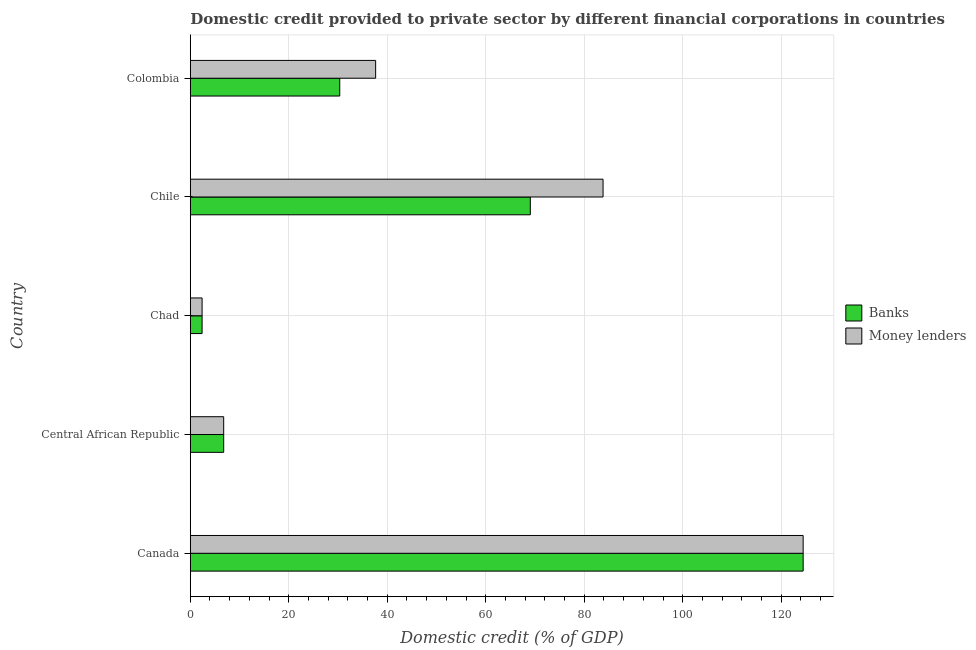Are the number of bars on each tick of the Y-axis equal?
Provide a short and direct response. Yes. How many bars are there on the 1st tick from the top?
Ensure brevity in your answer.  2. How many bars are there on the 4th tick from the bottom?
Provide a succinct answer. 2. What is the label of the 5th group of bars from the top?
Your response must be concise. Canada. What is the domestic credit provided by banks in Colombia?
Your answer should be very brief. 30.35. Across all countries, what is the maximum domestic credit provided by money lenders?
Give a very brief answer. 124.46. Across all countries, what is the minimum domestic credit provided by banks?
Offer a very short reply. 2.4. In which country was the domestic credit provided by money lenders minimum?
Provide a succinct answer. Chad. What is the total domestic credit provided by banks in the graph?
Give a very brief answer. 233.04. What is the difference between the domestic credit provided by banks in Canada and that in Chile?
Provide a succinct answer. 55.41. What is the difference between the domestic credit provided by banks in Chad and the domestic credit provided by money lenders in Chile?
Provide a short and direct response. -81.43. What is the average domestic credit provided by banks per country?
Ensure brevity in your answer.  46.61. What is the difference between the domestic credit provided by money lenders and domestic credit provided by banks in Colombia?
Ensure brevity in your answer.  7.29. What is the ratio of the domestic credit provided by money lenders in Central African Republic to that in Colombia?
Ensure brevity in your answer.  0.18. Is the domestic credit provided by money lenders in Canada less than that in Chad?
Make the answer very short. No. What is the difference between the highest and the second highest domestic credit provided by money lenders?
Offer a terse response. 40.64. What is the difference between the highest and the lowest domestic credit provided by money lenders?
Make the answer very short. 122.06. In how many countries, is the domestic credit provided by money lenders greater than the average domestic credit provided by money lenders taken over all countries?
Keep it short and to the point. 2. Is the sum of the domestic credit provided by money lenders in Chile and Colombia greater than the maximum domestic credit provided by banks across all countries?
Your answer should be compact. No. What does the 2nd bar from the top in Canada represents?
Provide a short and direct response. Banks. What does the 1st bar from the bottom in Chad represents?
Your answer should be very brief. Banks. How many bars are there?
Give a very brief answer. 10. Are all the bars in the graph horizontal?
Ensure brevity in your answer.  Yes. What is the difference between two consecutive major ticks on the X-axis?
Ensure brevity in your answer.  20. Are the values on the major ticks of X-axis written in scientific E-notation?
Make the answer very short. No. Does the graph contain any zero values?
Keep it short and to the point. No. How many legend labels are there?
Offer a very short reply. 2. How are the legend labels stacked?
Ensure brevity in your answer.  Vertical. What is the title of the graph?
Your answer should be compact. Domestic credit provided to private sector by different financial corporations in countries. What is the label or title of the X-axis?
Your answer should be compact. Domestic credit (% of GDP). What is the Domestic credit (% of GDP) of Banks in Canada?
Your answer should be very brief. 124.46. What is the Domestic credit (% of GDP) of Money lenders in Canada?
Make the answer very short. 124.46. What is the Domestic credit (% of GDP) in Banks in Central African Republic?
Provide a succinct answer. 6.78. What is the Domestic credit (% of GDP) in Money lenders in Central African Republic?
Provide a succinct answer. 6.78. What is the Domestic credit (% of GDP) in Banks in Chad?
Keep it short and to the point. 2.4. What is the Domestic credit (% of GDP) of Money lenders in Chad?
Provide a succinct answer. 2.4. What is the Domestic credit (% of GDP) in Banks in Chile?
Give a very brief answer. 69.05. What is the Domestic credit (% of GDP) of Money lenders in Chile?
Offer a terse response. 83.82. What is the Domestic credit (% of GDP) in Banks in Colombia?
Give a very brief answer. 30.35. What is the Domestic credit (% of GDP) of Money lenders in Colombia?
Keep it short and to the point. 37.64. Across all countries, what is the maximum Domestic credit (% of GDP) of Banks?
Offer a very short reply. 124.46. Across all countries, what is the maximum Domestic credit (% of GDP) of Money lenders?
Make the answer very short. 124.46. Across all countries, what is the minimum Domestic credit (% of GDP) of Banks?
Your answer should be compact. 2.4. Across all countries, what is the minimum Domestic credit (% of GDP) in Money lenders?
Provide a short and direct response. 2.4. What is the total Domestic credit (% of GDP) in Banks in the graph?
Make the answer very short. 233.04. What is the total Domestic credit (% of GDP) in Money lenders in the graph?
Make the answer very short. 255.11. What is the difference between the Domestic credit (% of GDP) of Banks in Canada and that in Central African Republic?
Your response must be concise. 117.68. What is the difference between the Domestic credit (% of GDP) in Money lenders in Canada and that in Central African Republic?
Ensure brevity in your answer.  117.68. What is the difference between the Domestic credit (% of GDP) of Banks in Canada and that in Chad?
Provide a succinct answer. 122.06. What is the difference between the Domestic credit (% of GDP) of Money lenders in Canada and that in Chad?
Ensure brevity in your answer.  122.06. What is the difference between the Domestic credit (% of GDP) of Banks in Canada and that in Chile?
Provide a succinct answer. 55.41. What is the difference between the Domestic credit (% of GDP) in Money lenders in Canada and that in Chile?
Your answer should be compact. 40.64. What is the difference between the Domestic credit (% of GDP) of Banks in Canada and that in Colombia?
Offer a very short reply. 94.11. What is the difference between the Domestic credit (% of GDP) in Money lenders in Canada and that in Colombia?
Keep it short and to the point. 86.82. What is the difference between the Domestic credit (% of GDP) in Banks in Central African Republic and that in Chad?
Offer a very short reply. 4.39. What is the difference between the Domestic credit (% of GDP) of Money lenders in Central African Republic and that in Chad?
Give a very brief answer. 4.39. What is the difference between the Domestic credit (% of GDP) of Banks in Central African Republic and that in Chile?
Give a very brief answer. -62.27. What is the difference between the Domestic credit (% of GDP) of Money lenders in Central African Republic and that in Chile?
Offer a very short reply. -77.04. What is the difference between the Domestic credit (% of GDP) of Banks in Central African Republic and that in Colombia?
Make the answer very short. -23.57. What is the difference between the Domestic credit (% of GDP) in Money lenders in Central African Republic and that in Colombia?
Offer a very short reply. -30.86. What is the difference between the Domestic credit (% of GDP) of Banks in Chad and that in Chile?
Ensure brevity in your answer.  -66.65. What is the difference between the Domestic credit (% of GDP) of Money lenders in Chad and that in Chile?
Ensure brevity in your answer.  -81.43. What is the difference between the Domestic credit (% of GDP) of Banks in Chad and that in Colombia?
Offer a very short reply. -27.95. What is the difference between the Domestic credit (% of GDP) in Money lenders in Chad and that in Colombia?
Give a very brief answer. -35.24. What is the difference between the Domestic credit (% of GDP) in Banks in Chile and that in Colombia?
Provide a succinct answer. 38.7. What is the difference between the Domestic credit (% of GDP) in Money lenders in Chile and that in Colombia?
Give a very brief answer. 46.19. What is the difference between the Domestic credit (% of GDP) in Banks in Canada and the Domestic credit (% of GDP) in Money lenders in Central African Republic?
Keep it short and to the point. 117.68. What is the difference between the Domestic credit (% of GDP) in Banks in Canada and the Domestic credit (% of GDP) in Money lenders in Chad?
Offer a very short reply. 122.06. What is the difference between the Domestic credit (% of GDP) in Banks in Canada and the Domestic credit (% of GDP) in Money lenders in Chile?
Provide a succinct answer. 40.64. What is the difference between the Domestic credit (% of GDP) of Banks in Canada and the Domestic credit (% of GDP) of Money lenders in Colombia?
Keep it short and to the point. 86.82. What is the difference between the Domestic credit (% of GDP) of Banks in Central African Republic and the Domestic credit (% of GDP) of Money lenders in Chad?
Offer a very short reply. 4.39. What is the difference between the Domestic credit (% of GDP) in Banks in Central African Republic and the Domestic credit (% of GDP) in Money lenders in Chile?
Ensure brevity in your answer.  -77.04. What is the difference between the Domestic credit (% of GDP) in Banks in Central African Republic and the Domestic credit (% of GDP) in Money lenders in Colombia?
Make the answer very short. -30.86. What is the difference between the Domestic credit (% of GDP) in Banks in Chad and the Domestic credit (% of GDP) in Money lenders in Chile?
Make the answer very short. -81.43. What is the difference between the Domestic credit (% of GDP) of Banks in Chad and the Domestic credit (% of GDP) of Money lenders in Colombia?
Provide a short and direct response. -35.24. What is the difference between the Domestic credit (% of GDP) of Banks in Chile and the Domestic credit (% of GDP) of Money lenders in Colombia?
Your answer should be compact. 31.41. What is the average Domestic credit (% of GDP) in Banks per country?
Offer a terse response. 46.61. What is the average Domestic credit (% of GDP) of Money lenders per country?
Your answer should be very brief. 51.02. What is the difference between the Domestic credit (% of GDP) of Banks and Domestic credit (% of GDP) of Money lenders in Central African Republic?
Offer a very short reply. 0. What is the difference between the Domestic credit (% of GDP) of Banks and Domestic credit (% of GDP) of Money lenders in Chad?
Keep it short and to the point. 0. What is the difference between the Domestic credit (% of GDP) of Banks and Domestic credit (% of GDP) of Money lenders in Chile?
Your answer should be compact. -14.77. What is the difference between the Domestic credit (% of GDP) of Banks and Domestic credit (% of GDP) of Money lenders in Colombia?
Offer a very short reply. -7.29. What is the ratio of the Domestic credit (% of GDP) of Banks in Canada to that in Central African Republic?
Provide a short and direct response. 18.35. What is the ratio of the Domestic credit (% of GDP) in Money lenders in Canada to that in Central African Republic?
Your answer should be very brief. 18.35. What is the ratio of the Domestic credit (% of GDP) of Banks in Canada to that in Chad?
Keep it short and to the point. 51.91. What is the ratio of the Domestic credit (% of GDP) of Money lenders in Canada to that in Chad?
Keep it short and to the point. 51.91. What is the ratio of the Domestic credit (% of GDP) of Banks in Canada to that in Chile?
Ensure brevity in your answer.  1.8. What is the ratio of the Domestic credit (% of GDP) in Money lenders in Canada to that in Chile?
Offer a terse response. 1.48. What is the ratio of the Domestic credit (% of GDP) of Banks in Canada to that in Colombia?
Keep it short and to the point. 4.1. What is the ratio of the Domestic credit (% of GDP) of Money lenders in Canada to that in Colombia?
Keep it short and to the point. 3.31. What is the ratio of the Domestic credit (% of GDP) of Banks in Central African Republic to that in Chad?
Offer a terse response. 2.83. What is the ratio of the Domestic credit (% of GDP) of Money lenders in Central African Republic to that in Chad?
Your response must be concise. 2.83. What is the ratio of the Domestic credit (% of GDP) in Banks in Central African Republic to that in Chile?
Offer a very short reply. 0.1. What is the ratio of the Domestic credit (% of GDP) in Money lenders in Central African Republic to that in Chile?
Ensure brevity in your answer.  0.08. What is the ratio of the Domestic credit (% of GDP) of Banks in Central African Republic to that in Colombia?
Your response must be concise. 0.22. What is the ratio of the Domestic credit (% of GDP) in Money lenders in Central African Republic to that in Colombia?
Your response must be concise. 0.18. What is the ratio of the Domestic credit (% of GDP) in Banks in Chad to that in Chile?
Offer a very short reply. 0.03. What is the ratio of the Domestic credit (% of GDP) in Money lenders in Chad to that in Chile?
Your response must be concise. 0.03. What is the ratio of the Domestic credit (% of GDP) in Banks in Chad to that in Colombia?
Keep it short and to the point. 0.08. What is the ratio of the Domestic credit (% of GDP) of Money lenders in Chad to that in Colombia?
Your answer should be very brief. 0.06. What is the ratio of the Domestic credit (% of GDP) of Banks in Chile to that in Colombia?
Keep it short and to the point. 2.28. What is the ratio of the Domestic credit (% of GDP) of Money lenders in Chile to that in Colombia?
Your response must be concise. 2.23. What is the difference between the highest and the second highest Domestic credit (% of GDP) in Banks?
Your response must be concise. 55.41. What is the difference between the highest and the second highest Domestic credit (% of GDP) in Money lenders?
Offer a very short reply. 40.64. What is the difference between the highest and the lowest Domestic credit (% of GDP) in Banks?
Give a very brief answer. 122.06. What is the difference between the highest and the lowest Domestic credit (% of GDP) in Money lenders?
Provide a succinct answer. 122.06. 